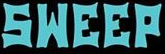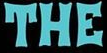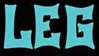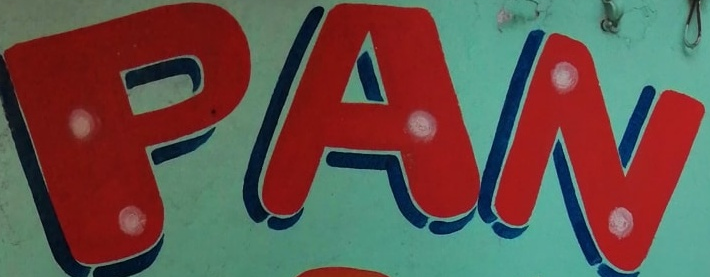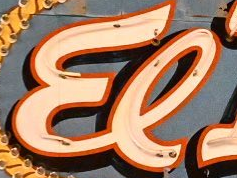Read the text from these images in sequence, separated by a semicolon. SWEEP; THE; LEG; PAN; El 